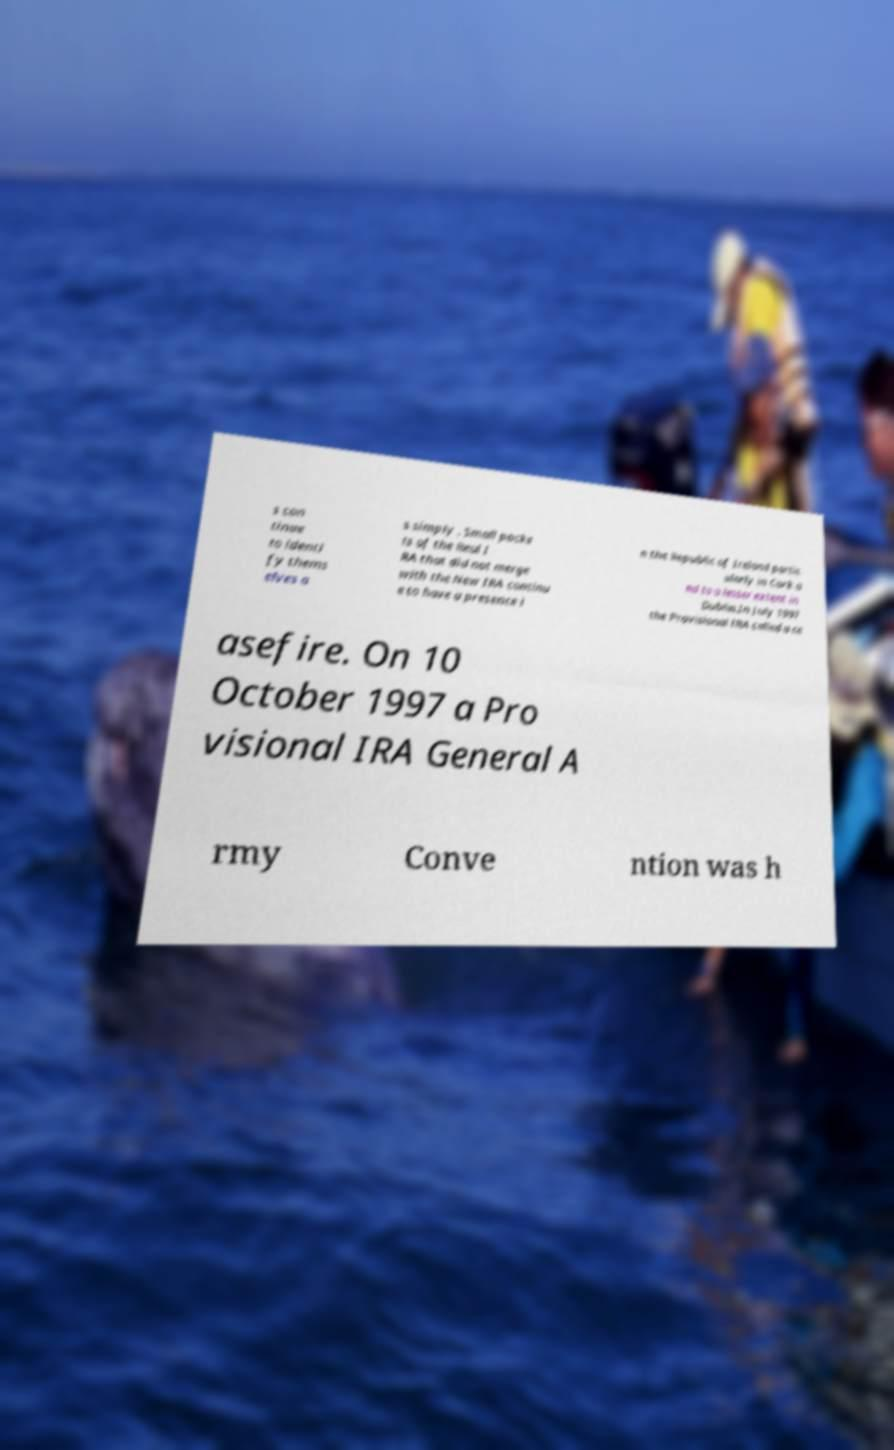I need the written content from this picture converted into text. Can you do that? s con tinue to identi fy thems elves a s simply . Small pocke ts of the Real I RA that did not merge with the New IRA continu e to have a presence i n the Republic of Ireland partic ularly in Cork a nd to a lesser extent in Dublin.In July 1997 the Provisional IRA called a ce asefire. On 10 October 1997 a Pro visional IRA General A rmy Conve ntion was h 